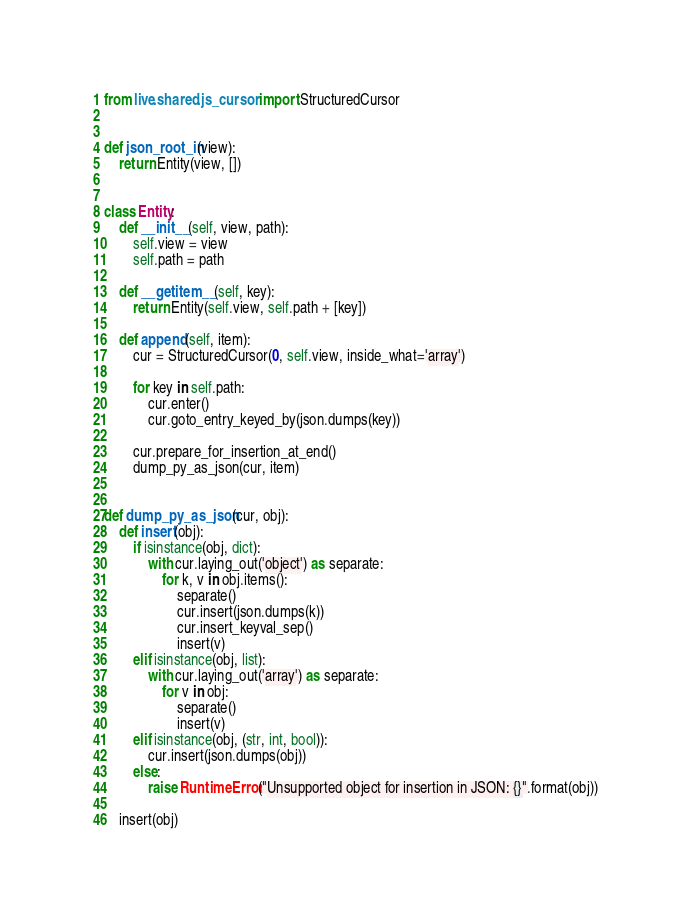Convert code to text. <code><loc_0><loc_0><loc_500><loc_500><_Python_>from live.shared.js_cursor import StructuredCursor


def json_root_in(view):
    return Entity(view, [])


class Entity:
    def __init__(self, view, path):
        self.view = view
        self.path = path

    def __getitem__(self, key):
        return Entity(self.view, self.path + [key])

    def append(self, item):
        cur = StructuredCursor(0, self.view, inside_what='array')

        for key in self.path:
            cur.enter()
            cur.goto_entry_keyed_by(json.dumps(key))

        cur.prepare_for_insertion_at_end()
        dump_py_as_json(cur, item)


def dump_py_as_json(cur, obj):
    def insert(obj):
        if isinstance(obj, dict):
            with cur.laying_out('object') as separate:
                for k, v in obj.items():
                    separate()
                    cur.insert(json.dumps(k))
                    cur.insert_keyval_sep()
                    insert(v)
        elif isinstance(obj, list):
            with cur.laying_out('array') as separate:
                for v in obj:
                    separate()
                    insert(v)
        elif isinstance(obj, (str, int, bool)):
            cur.insert(json.dumps(obj))
        else:
            raise RuntimeError("Unsupported object for insertion in JSON: {}".format(obj))

    insert(obj)
</code> 